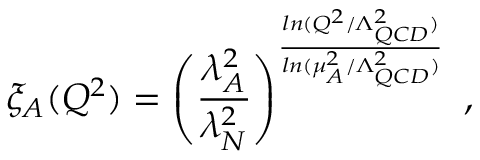<formula> <loc_0><loc_0><loc_500><loc_500>\xi _ { A } ( Q ^ { 2 } ) = \left ( \frac { \lambda _ { A } ^ { 2 } } { \lambda _ { N } ^ { 2 } } \right ) ^ { \frac { \ln ( Q ^ { 2 } / \Lambda _ { Q C D } ^ { 2 } ) } { \ln ( \mu _ { A } ^ { 2 } / \Lambda _ { Q C D } ^ { 2 } ) } } ,</formula> 